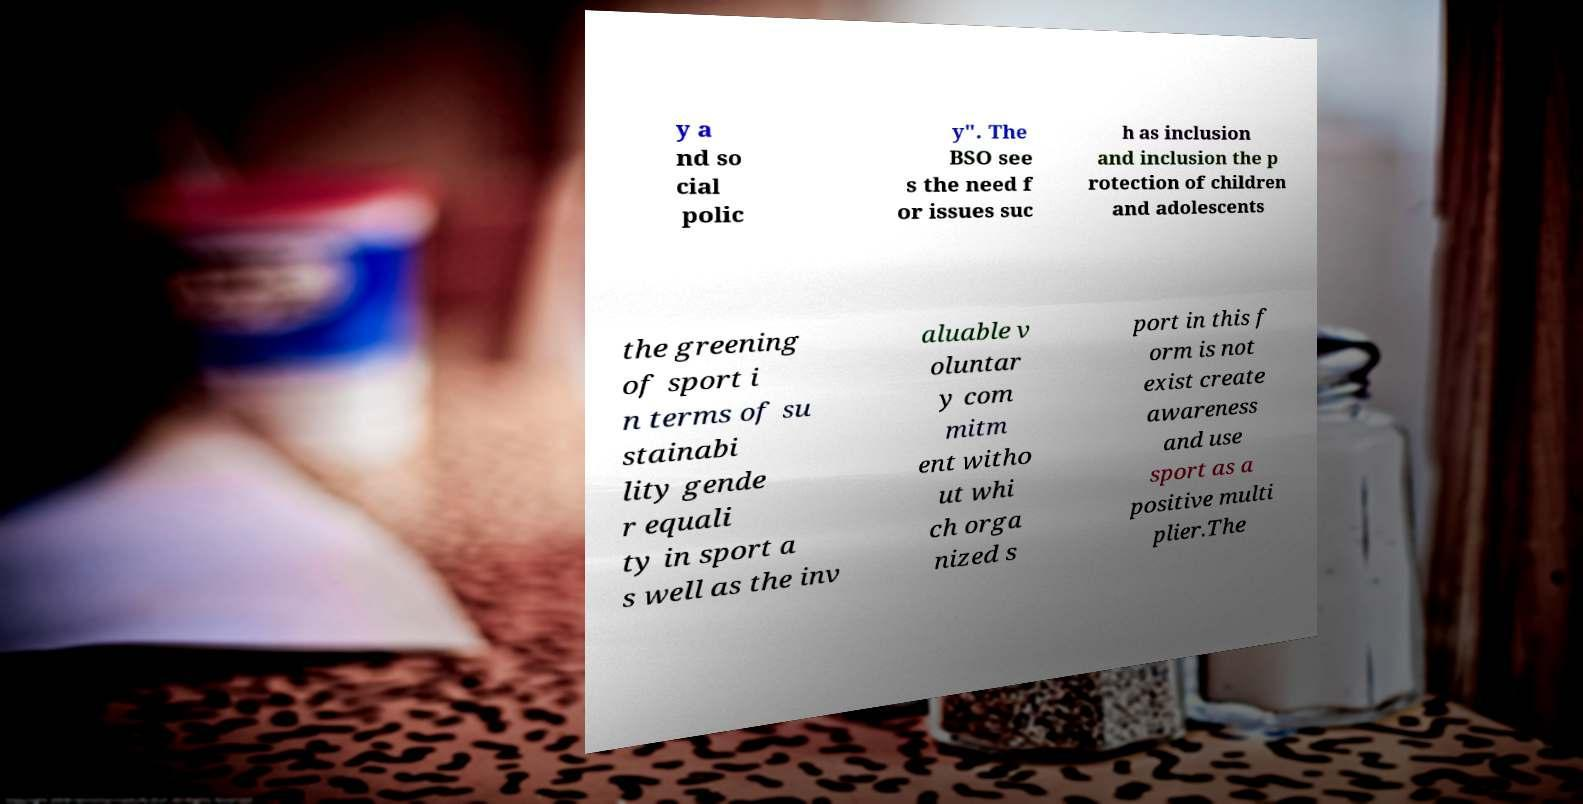Please identify and transcribe the text found in this image. y a nd so cial polic y". The BSO see s the need f or issues suc h as inclusion and inclusion the p rotection of children and adolescents the greening of sport i n terms of su stainabi lity gende r equali ty in sport a s well as the inv aluable v oluntar y com mitm ent witho ut whi ch orga nized s port in this f orm is not exist create awareness and use sport as a positive multi plier.The 